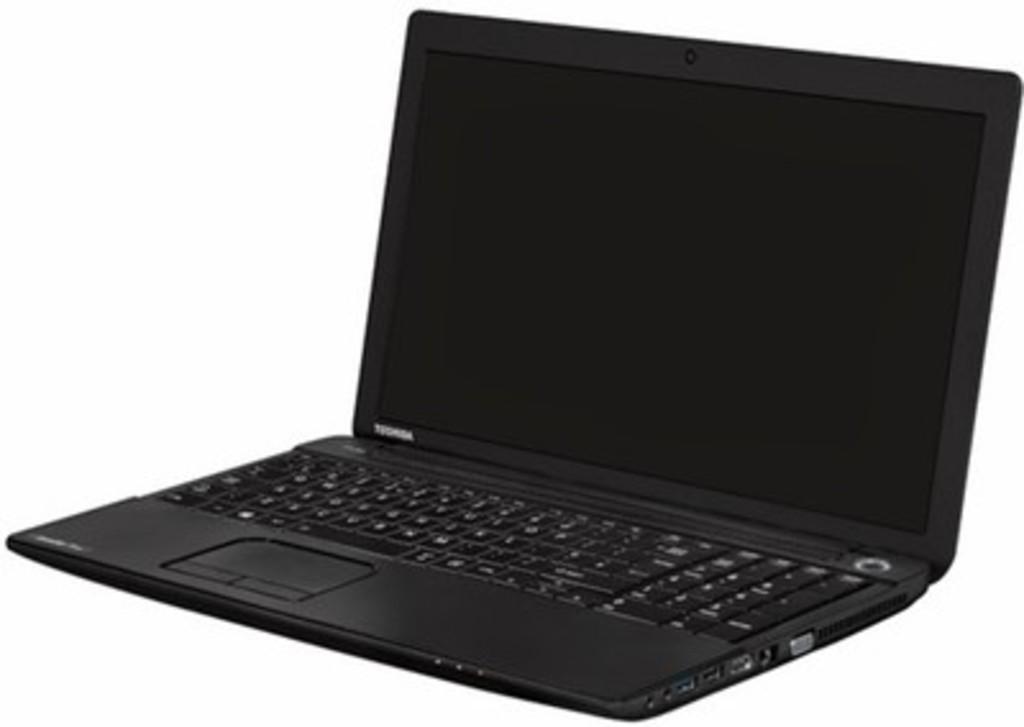What brand of laptop?
Make the answer very short. Toshiba. What brand of laptop is shown?
Provide a short and direct response. Toshiba. 